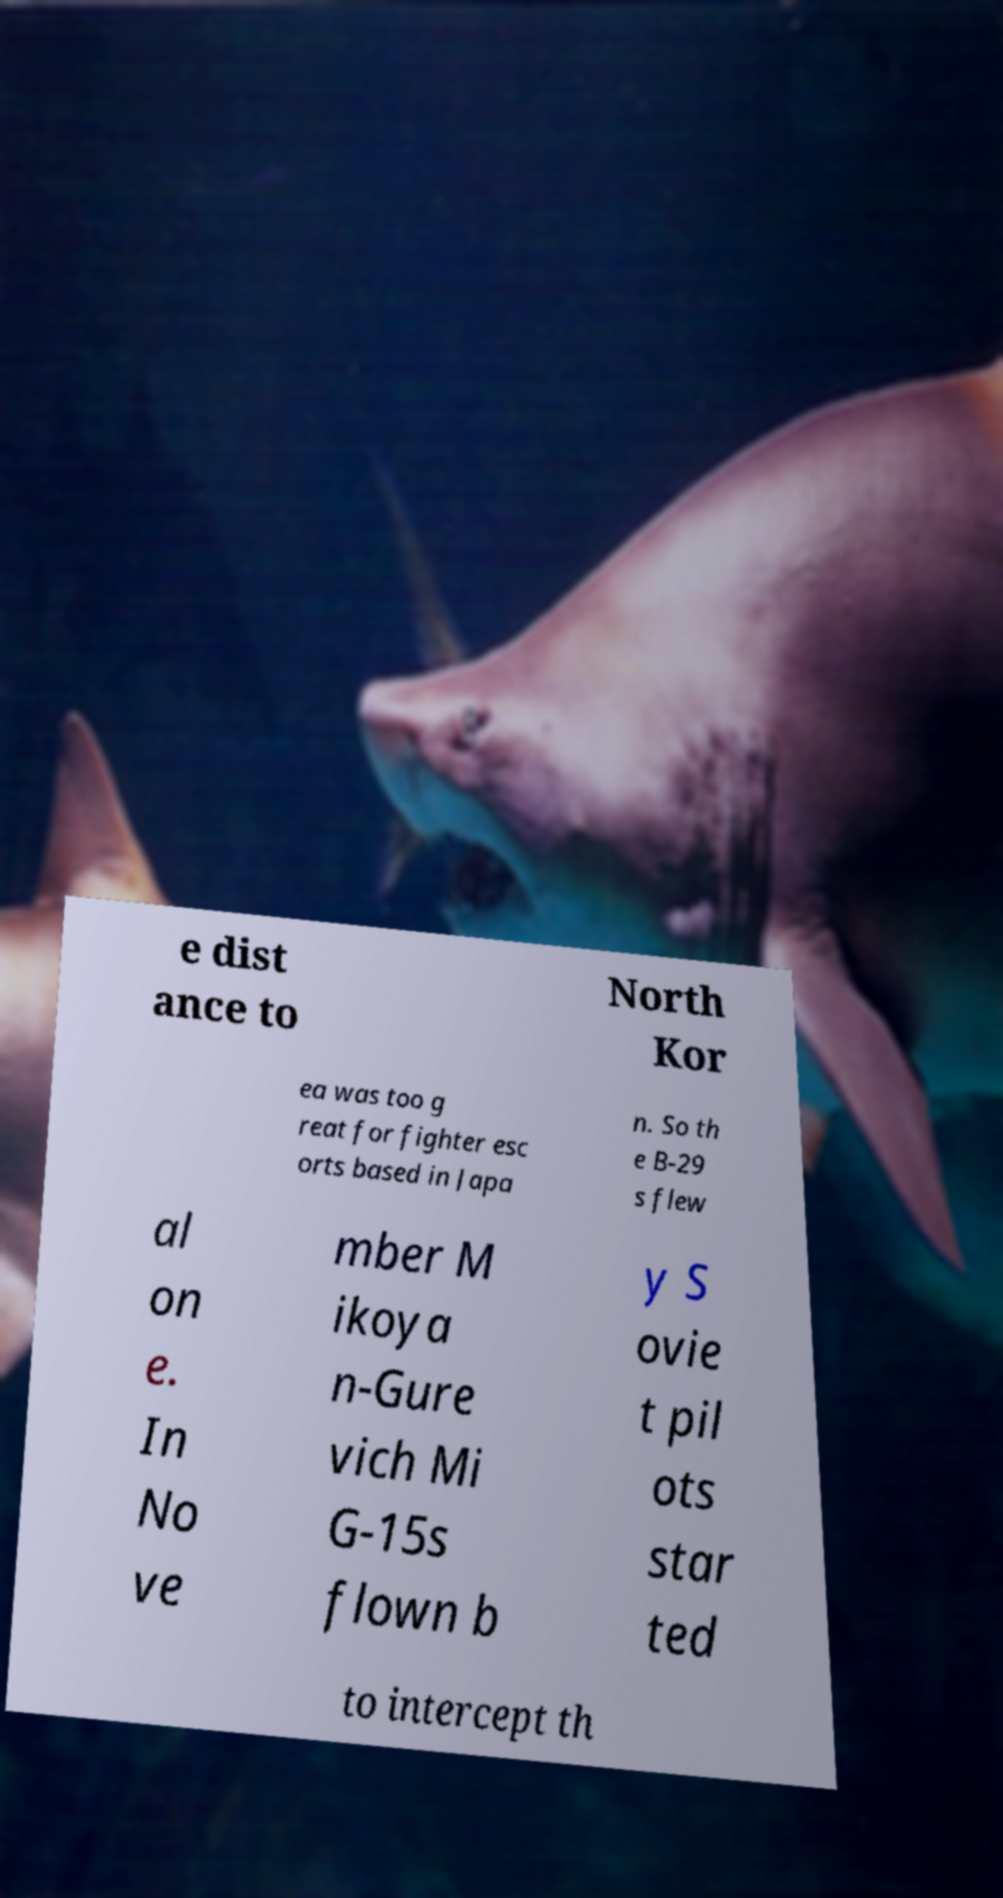Please read and relay the text visible in this image. What does it say? e dist ance to North Kor ea was too g reat for fighter esc orts based in Japa n. So th e B-29 s flew al on e. In No ve mber M ikoya n-Gure vich Mi G-15s flown b y S ovie t pil ots star ted to intercept th 